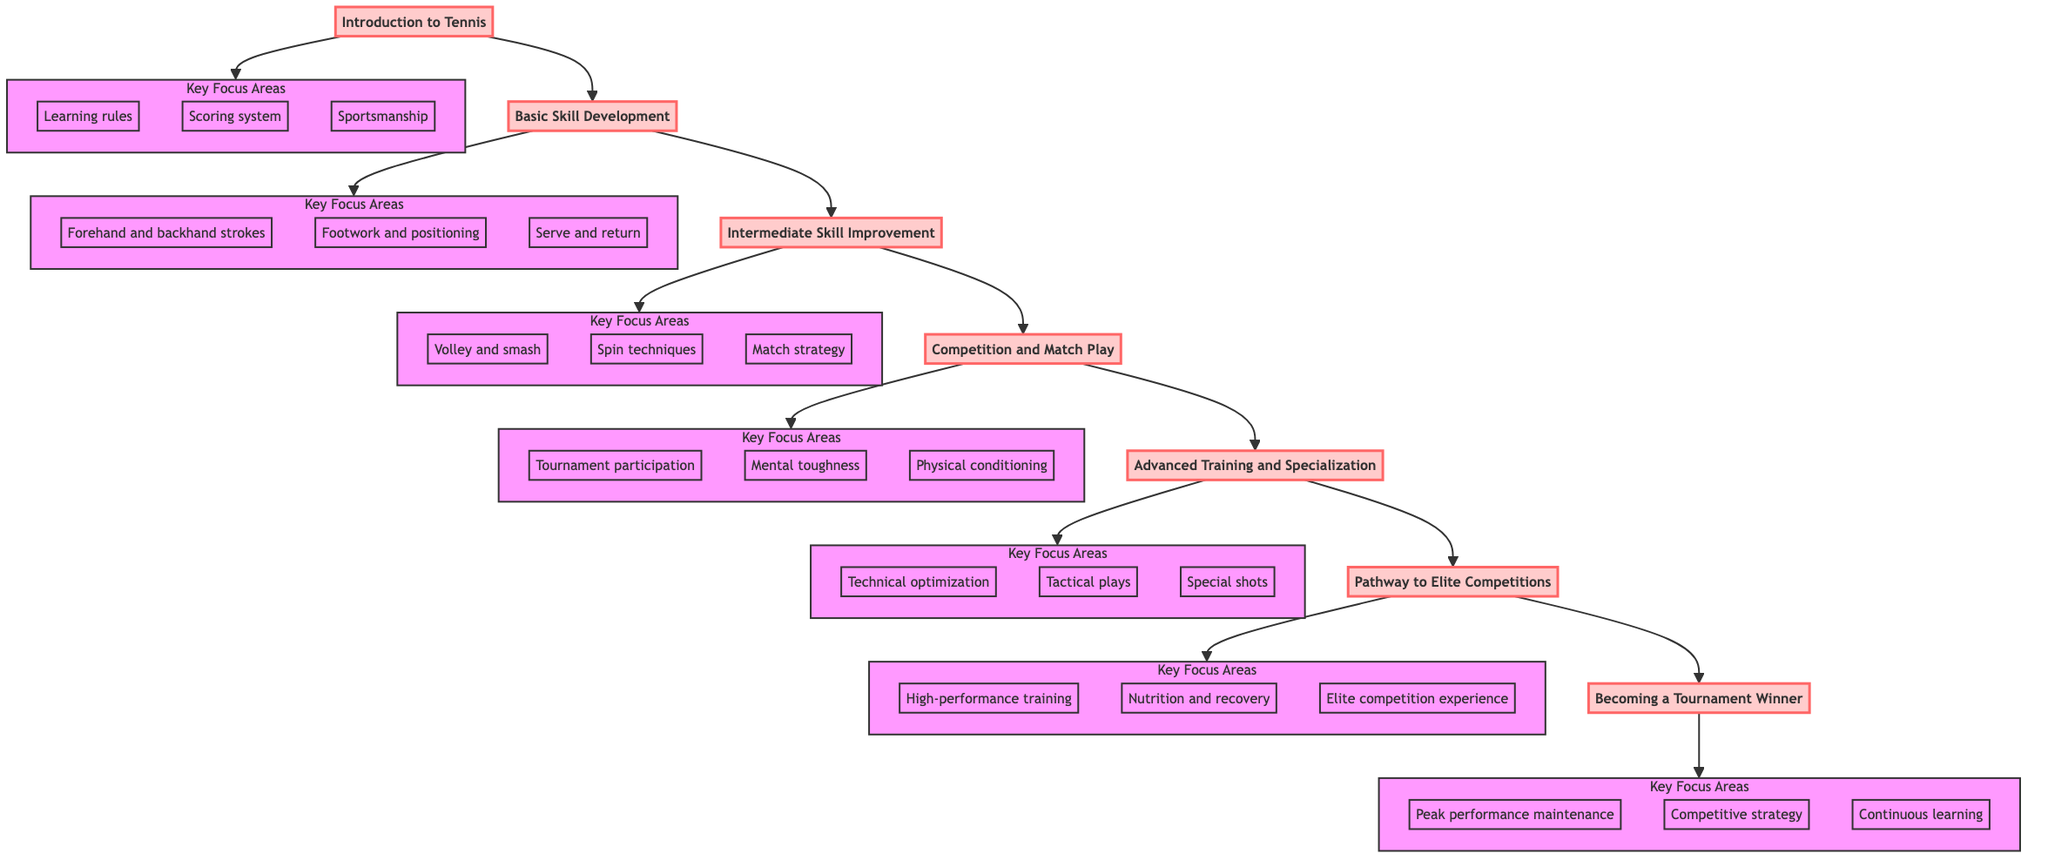What is the first stage in developing a junior tennis player? The diagram shows the stages of development starting from the bottom. The first stage at the bottom is labeled "Introduction to Tennis."
Answer: Introduction to Tennis How many key focus areas are listed in the "Advanced Training and Specialization" stage? The "Advanced Training and Specialization" stage has three key focus areas: technical optimization, tactical plays, and special shots. Counting these gives us three.
Answer: 3 What stage follows "Competition and Match Play"? The flow of the diagram shows an upward progression. Directly above "Competition and Match Play," the next stage listed is "Advanced Training and Specialization."
Answer: Advanced Training and Specialization Which stage emphasizes "Mental toughness" as a key focus area? The "Competition and Match Play" stage contains the key focus area "Mental toughness." By checking the key focus areas for that stage, we confirm this emphasis.
Answer: Competition and Match Play What actions are suggested in the "Pathway to Elite Competitions" stage? The actions listed under "Pathway to Elite Competitions" are "National and international junior events," "Professional tennis coaching," and "Specific training regimes."
Answer: National and international junior events, Professional tennis coaching, Specific training regimes How many stages are there from "Introduction to Tennis" to "Becoming a Tournament Winner"? The total number of distinct stages that flow upward from "Introduction to Tennis" to "Becoming a Tournament Winner" is seven: Introduction to Tennis, Basic Skill Development, Intermediate Skill Improvement, Competition and Match Play, Advanced Training and Specialization, Pathway to Elite Competitions, and Becoming a Tournament Winner.
Answer: 7 Which key focus area is associated with "Continuous learning"? The key focus area of "Continuous learning" is associated with the final stage of "Becoming a Tournament Winner," where it is listed as one of the three key focus areas.
Answer: Continuous learning What types of training are emphasized in the "Pathway to Elite Competitions"? In the "Pathway to Elite Competitions" stage, the key focus areas emphasize high-performance training, nutrition and recovery, and elite competition experience.
Answer: High-performance training, nutrition and recovery, elite competition experience 